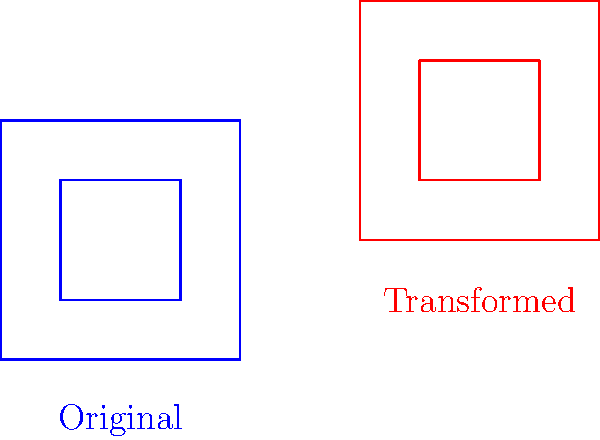A farmer wants to redesign their farm layout. The blue diagram represents the original layout, and the red diagram shows the desired transformed layout. Determine the sequence of transformations applied to convert the original farm layout to the new one. Express your answer as a series of steps in the correct order. To determine the sequence of transformations, we need to analyze the changes from the original (blue) layout to the transformed (red) layout. Let's break it down step-by-step:

1. Position: The entire farm layout has moved to the right and up. This indicates a translation.

2. Size: The overall size of the farm layout remains the same (2x2 units). There is no scaling involved.

3. Orientation: The layout maintains its original orientation. There is no rotation.

To calculate the translation:
- Original bottom-left corner: (0,0)
- Transformed bottom-left corner: (3,1)
- Translation vector: (3-0, 1-0) = (3,1)

Therefore, the only transformation applied is a translation of 3 units right and 1 unit up, which can be expressed as T(3,1) in transformation notation.
Answer: Translation T(3,1) 